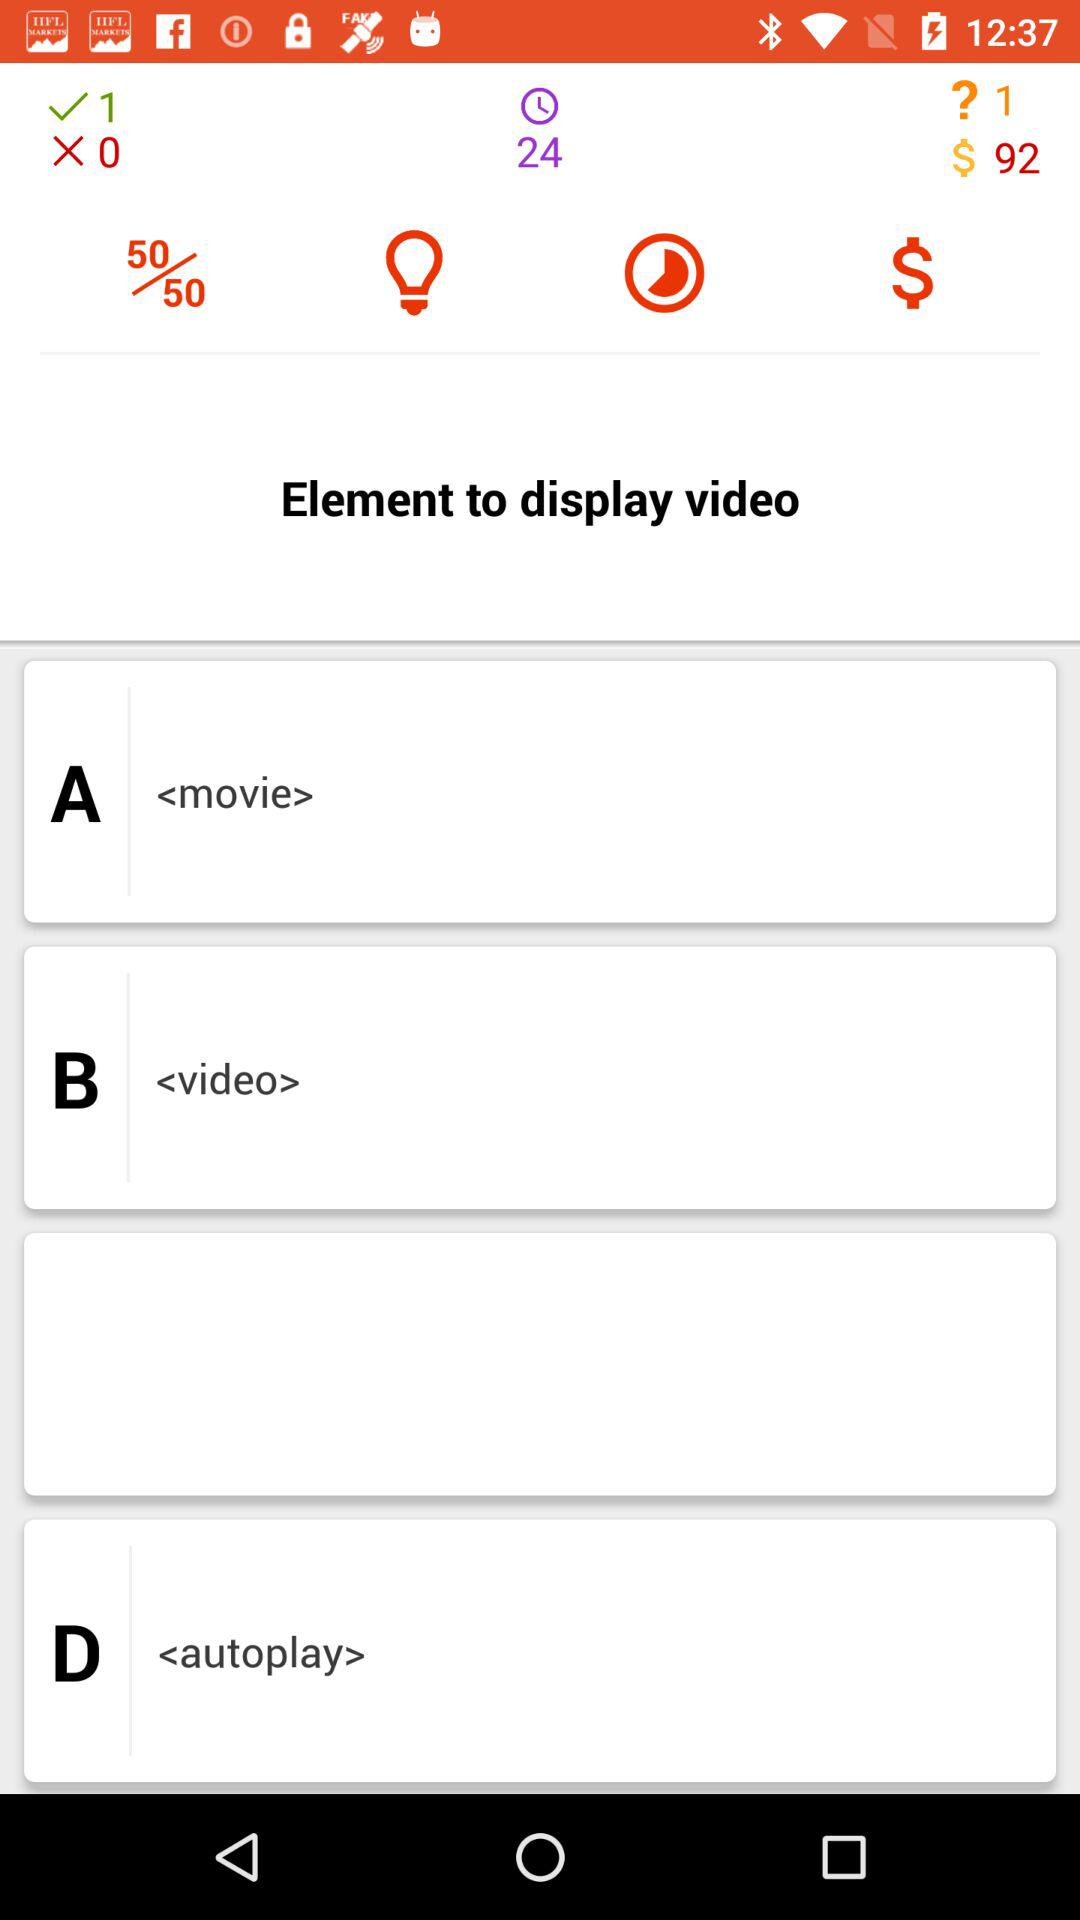What is the count of $? The count of $ is 92. 